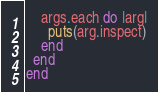<code> <loc_0><loc_0><loc_500><loc_500><_Ruby_>    args.each do |arg|
      puts(arg.inspect)
    end
  end
end
</code> 